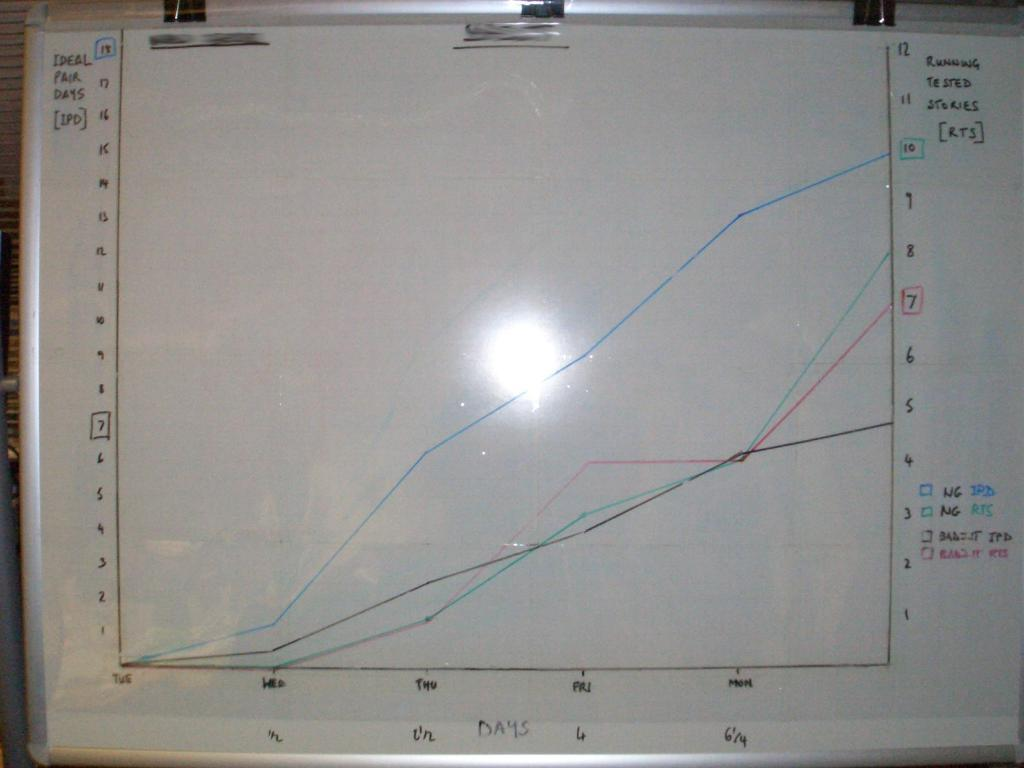<image>
Write a terse but informative summary of the picture. A graph on a whiteboard that has Ideal Pair Days on the x-axis. 